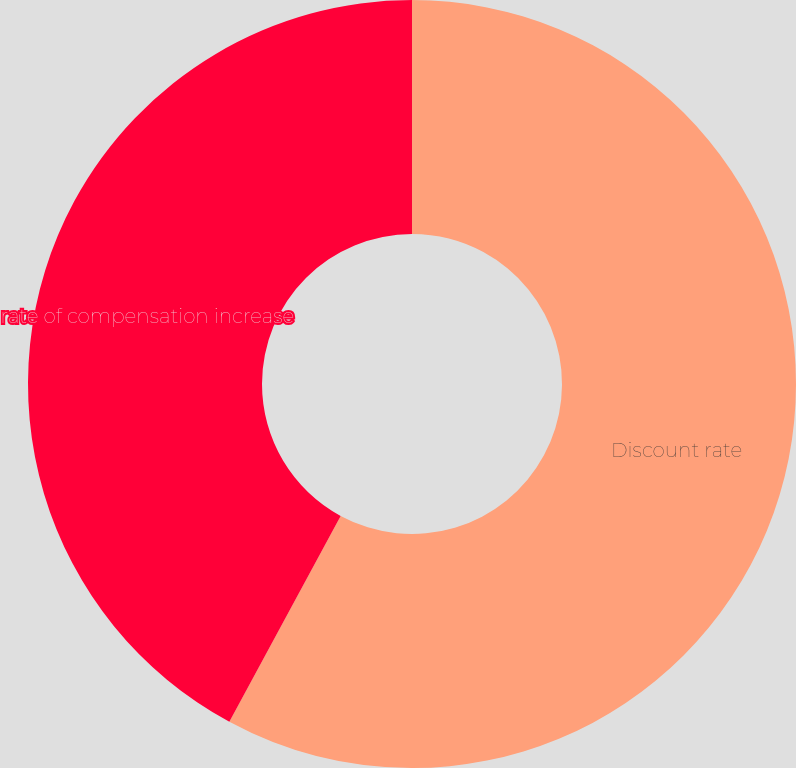<chart> <loc_0><loc_0><loc_500><loc_500><pie_chart><fcel>Discount rate<fcel>rate of compensation increase<nl><fcel>57.89%<fcel>42.11%<nl></chart> 